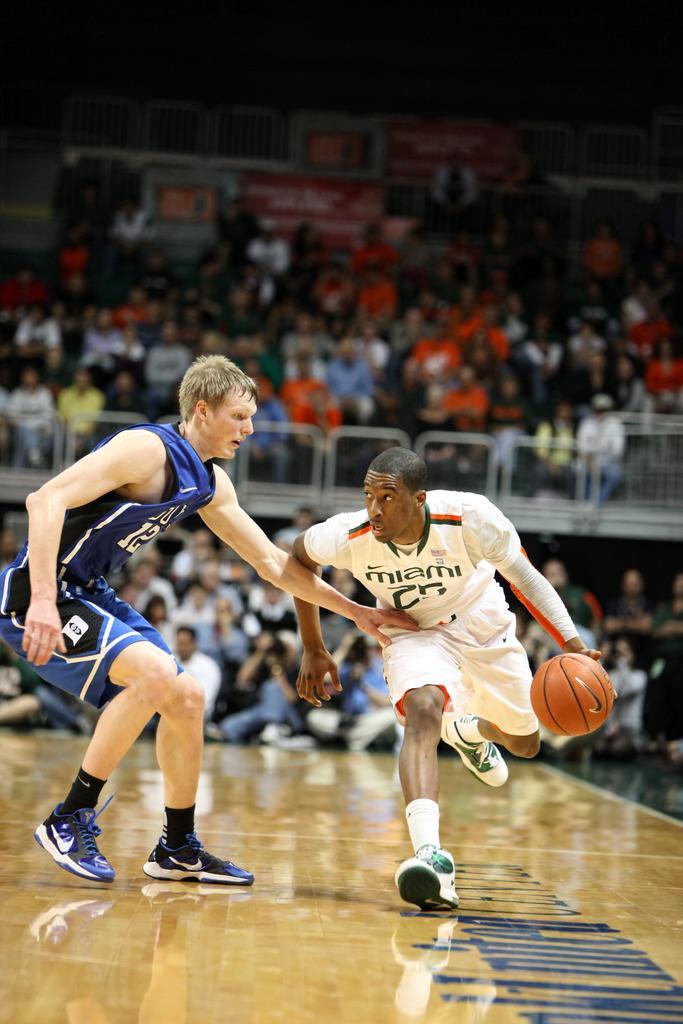Please provide a concise description of this image. In the given picture, we can see two basketball players playing the game, after that we can see the spectators. 